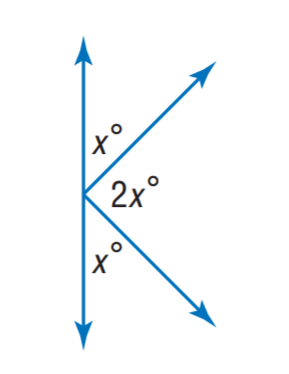Question: Find x.
Choices:
A. 30
B. 45
C. 60
D. 75
Answer with the letter. Answer: B 